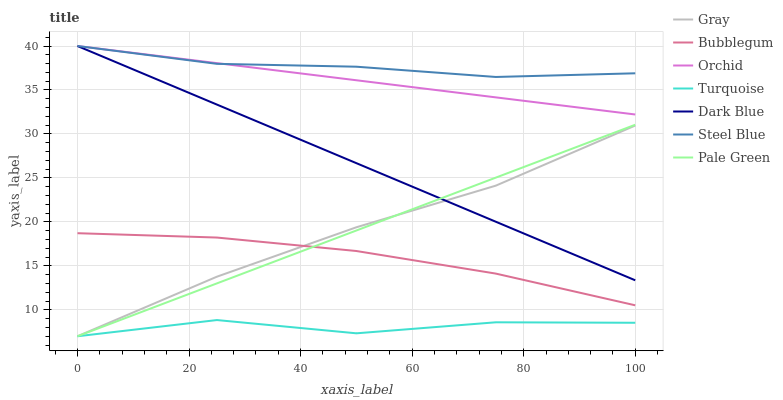Does Turquoise have the minimum area under the curve?
Answer yes or no. Yes. Does Steel Blue have the maximum area under the curve?
Answer yes or no. Yes. Does Steel Blue have the minimum area under the curve?
Answer yes or no. No. Does Turquoise have the maximum area under the curve?
Answer yes or no. No. Is Pale Green the smoothest?
Answer yes or no. Yes. Is Turquoise the roughest?
Answer yes or no. Yes. Is Steel Blue the smoothest?
Answer yes or no. No. Is Steel Blue the roughest?
Answer yes or no. No. Does Gray have the lowest value?
Answer yes or no. Yes. Does Steel Blue have the lowest value?
Answer yes or no. No. Does Orchid have the highest value?
Answer yes or no. Yes. Does Turquoise have the highest value?
Answer yes or no. No. Is Turquoise less than Dark Blue?
Answer yes or no. Yes. Is Steel Blue greater than Turquoise?
Answer yes or no. Yes. Does Steel Blue intersect Orchid?
Answer yes or no. Yes. Is Steel Blue less than Orchid?
Answer yes or no. No. Is Steel Blue greater than Orchid?
Answer yes or no. No. Does Turquoise intersect Dark Blue?
Answer yes or no. No. 